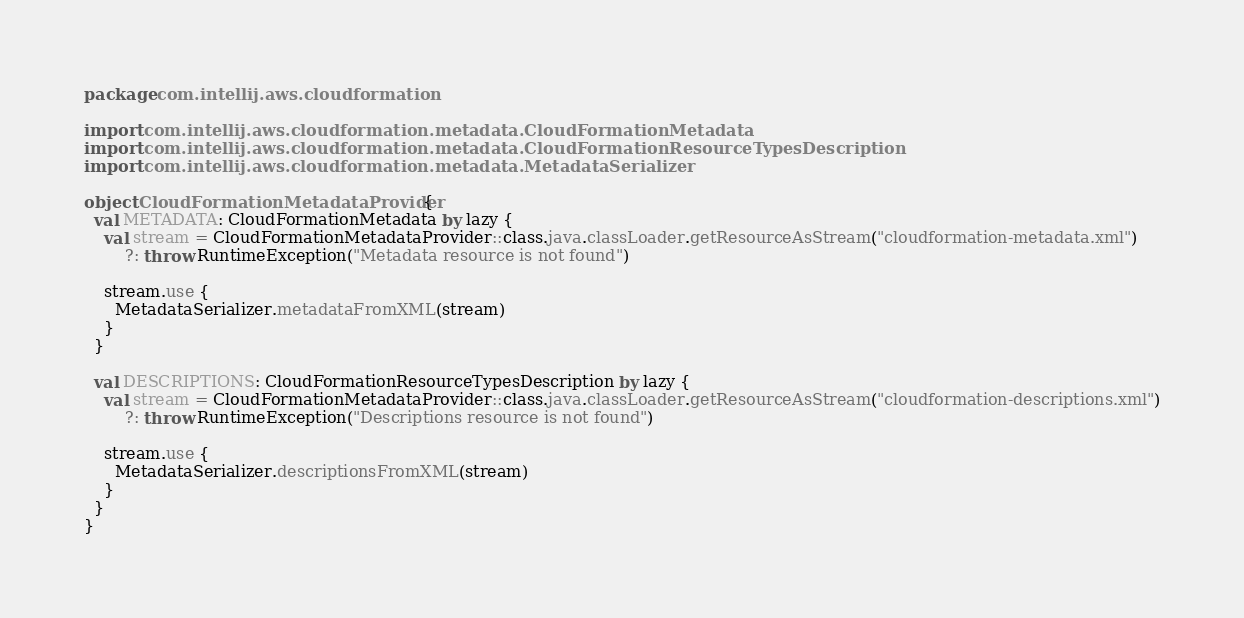<code> <loc_0><loc_0><loc_500><loc_500><_Kotlin_>package com.intellij.aws.cloudformation

import com.intellij.aws.cloudformation.metadata.CloudFormationMetadata
import com.intellij.aws.cloudformation.metadata.CloudFormationResourceTypesDescription
import com.intellij.aws.cloudformation.metadata.MetadataSerializer

object CloudFormationMetadataProvider {
  val METADATA: CloudFormationMetadata by lazy {
    val stream = CloudFormationMetadataProvider::class.java.classLoader.getResourceAsStream("cloudformation-metadata.xml")
        ?: throw RuntimeException("Metadata resource is not found")

    stream.use {
      MetadataSerializer.metadataFromXML(stream)
    }
  }

  val DESCRIPTIONS: CloudFormationResourceTypesDescription by lazy {
    val stream = CloudFormationMetadataProvider::class.java.classLoader.getResourceAsStream("cloudformation-descriptions.xml")
        ?: throw RuntimeException("Descriptions resource is not found")

    stream.use {
      MetadataSerializer.descriptionsFromXML(stream)
    }
  }
}
</code> 